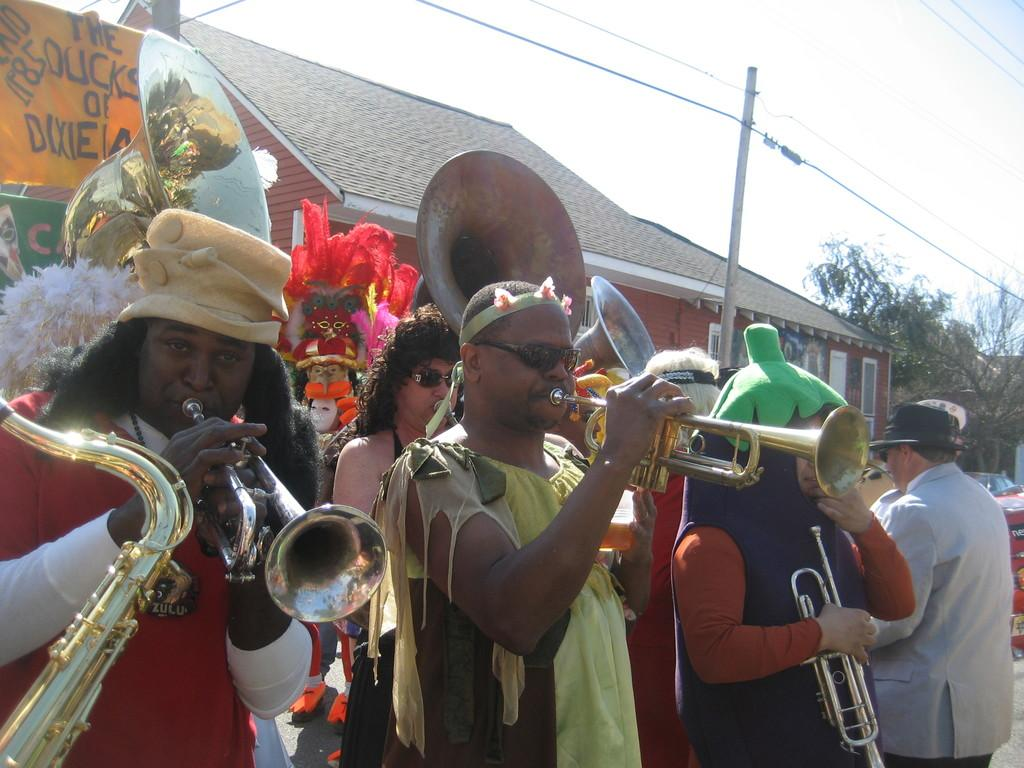What are the people in the image doing? The people in the image are playing musical instruments. What can be seen in the background of the image? There are buildings, trees, a pole with wires, and the sky visible in the background of the image. What type of grain is being harvested in the image? There is no grain present in the image; it features people playing musical instruments and a background with buildings, trees, a pole with wires, and the sky. 